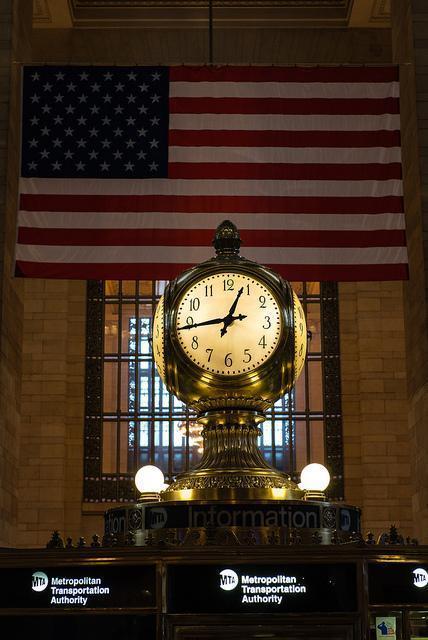How many light sources are in this picture?
Give a very brief answer. 3. How many stripes are on the flag?
Give a very brief answer. 13. 